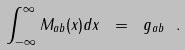Convert formula to latex. <formula><loc_0><loc_0><loc_500><loc_500>\int _ { - \infty } ^ { \infty } M _ { a b } ( x ) d x \ = \ g _ { a b } \ .</formula> 